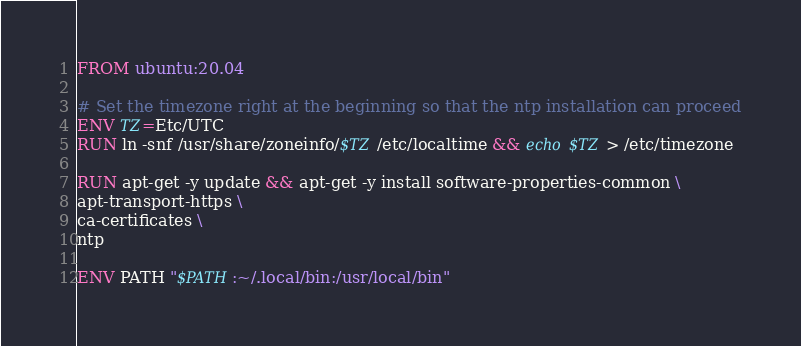<code> <loc_0><loc_0><loc_500><loc_500><_Dockerfile_>FROM ubuntu:20.04

# Set the timezone right at the beginning so that the ntp installation can proceed
ENV TZ=Etc/UTC
RUN ln -snf /usr/share/zoneinfo/$TZ /etc/localtime && echo $TZ > /etc/timezone

RUN apt-get -y update && apt-get -y install software-properties-common \
apt-transport-https \
ca-certificates \
ntp

ENV PATH "$PATH:~/.local/bin:/usr/local/bin"
</code> 